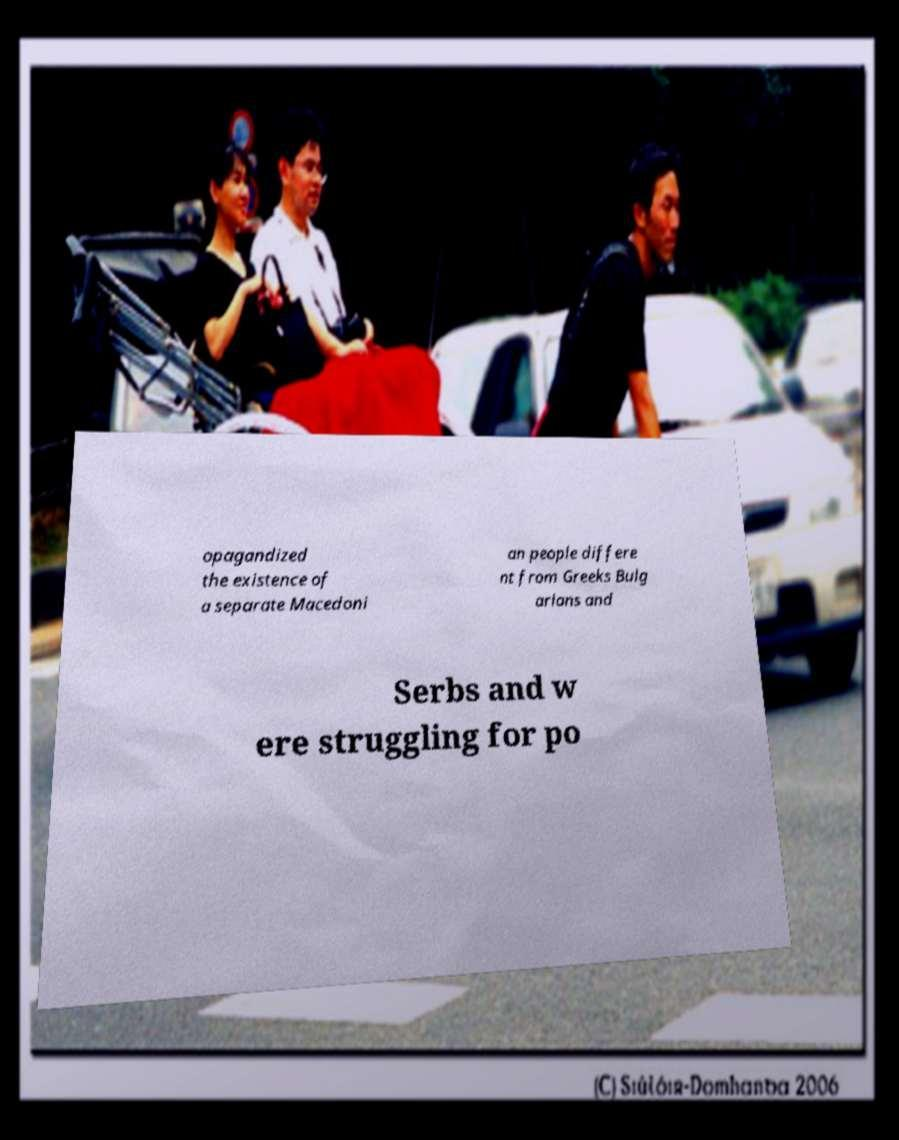For documentation purposes, I need the text within this image transcribed. Could you provide that? opagandized the existence of a separate Macedoni an people differe nt from Greeks Bulg arians and Serbs and w ere struggling for po 